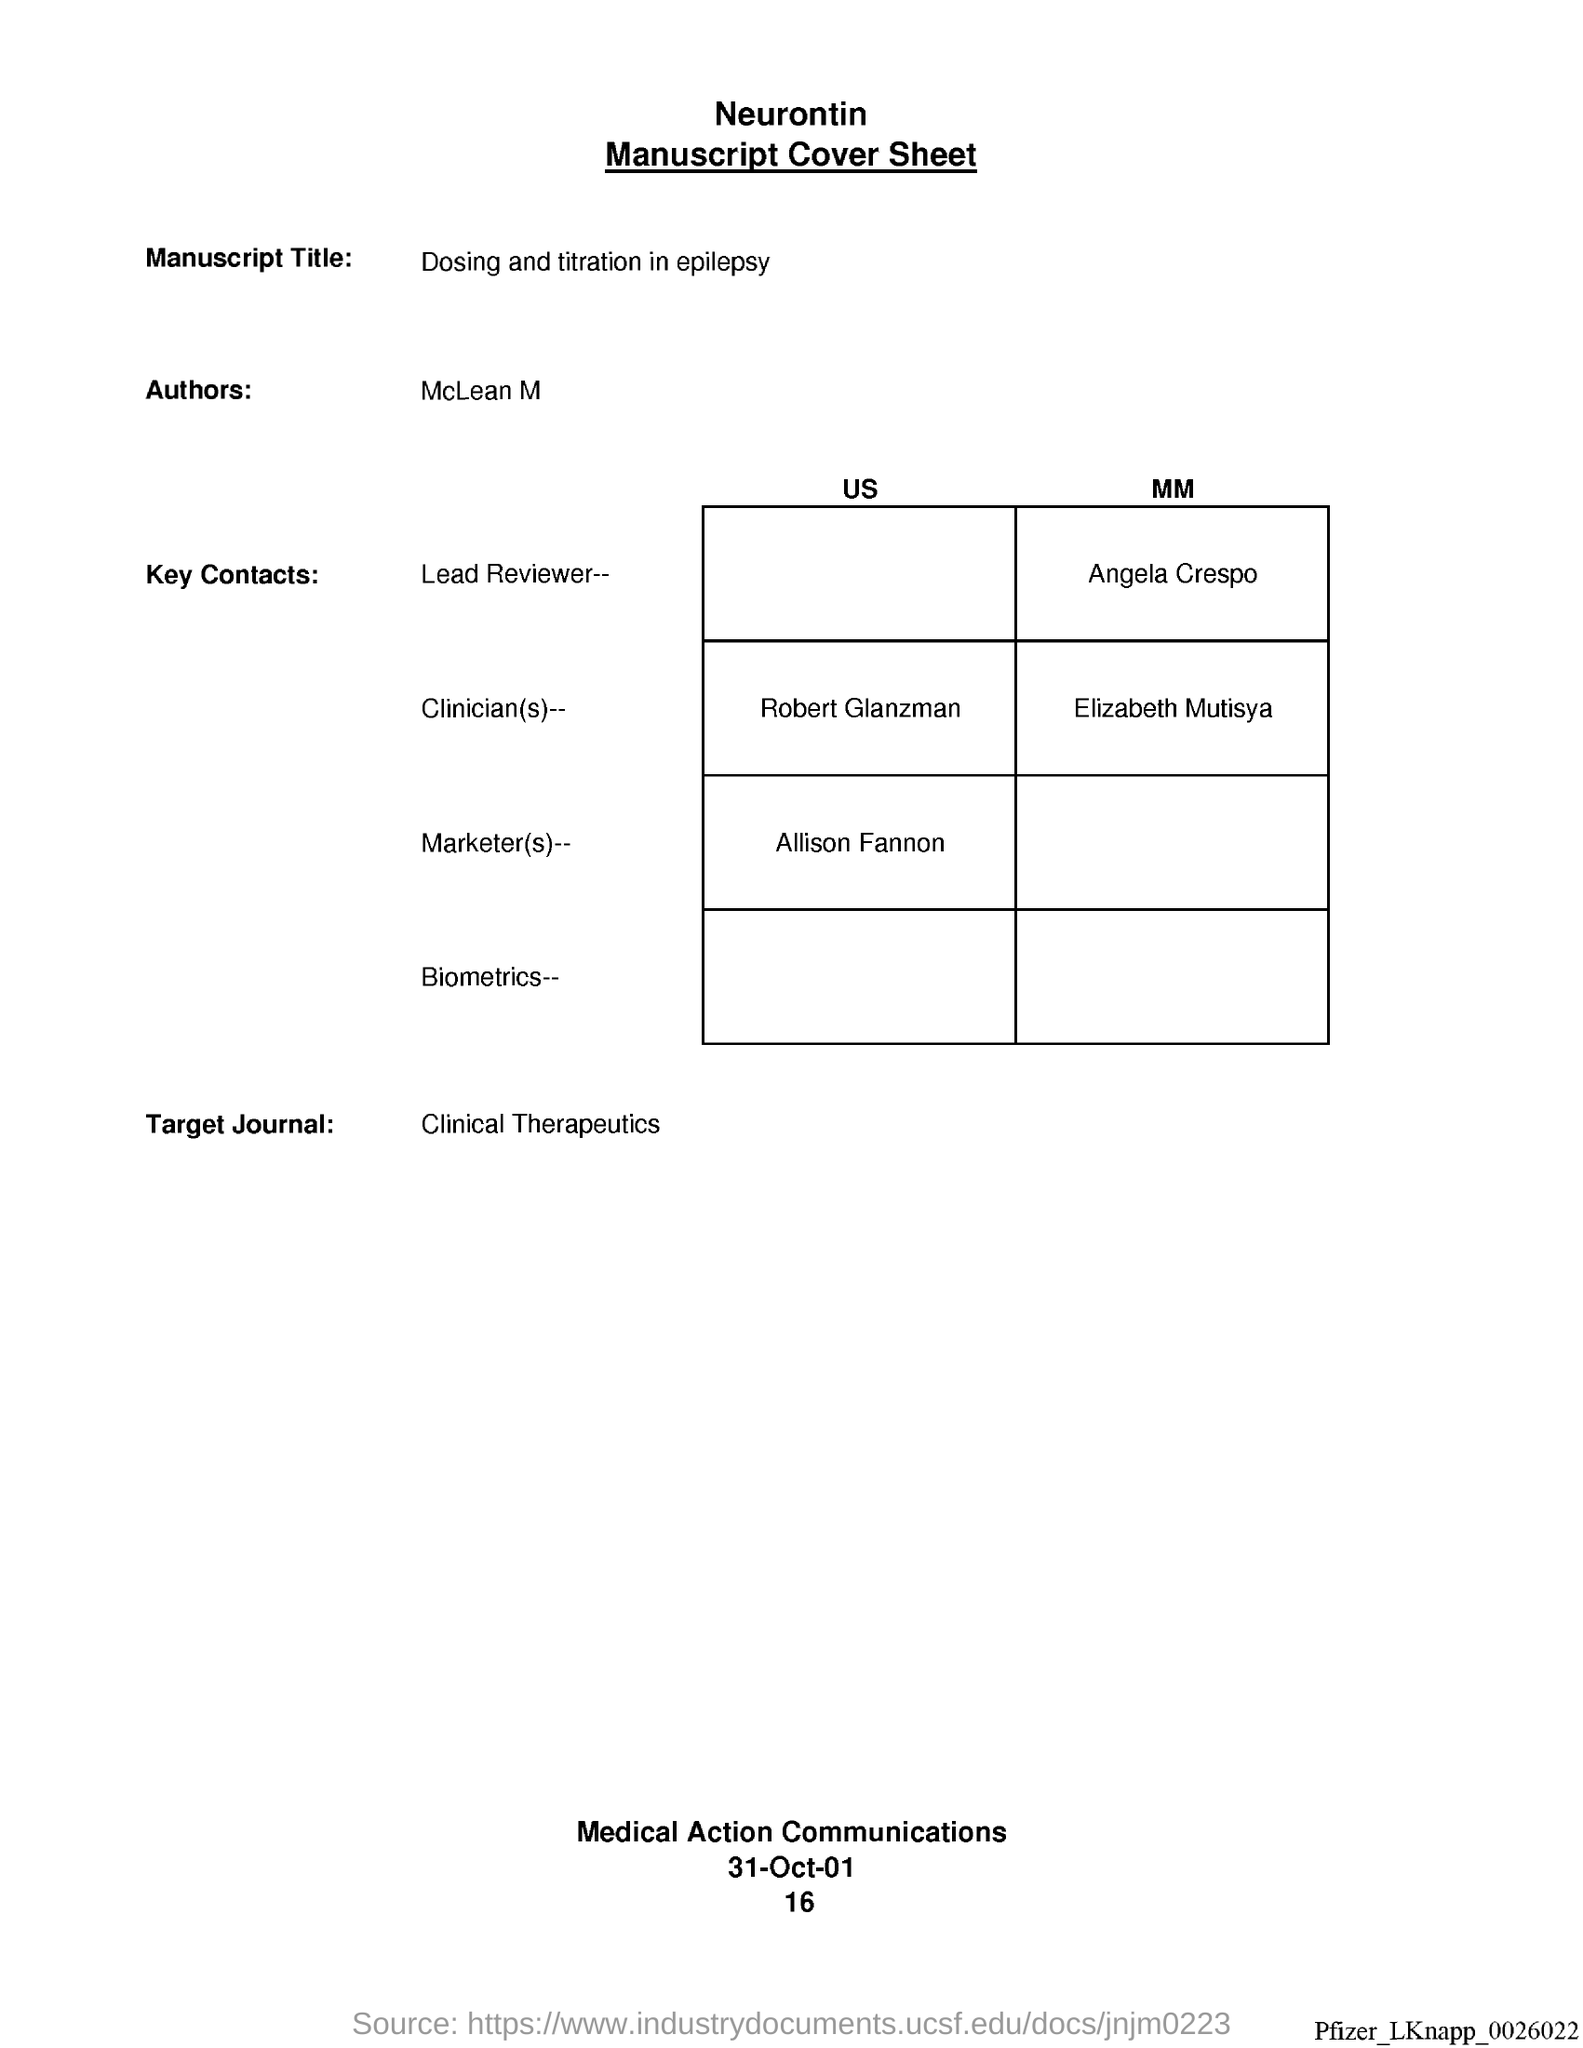Mention a couple of crucial points in this snapshot. The author of this text is McLean M.. The Target Journal is a publication named Clinical Therapeutics. The date is 31 October 2001. The manuscript title is "Dosing and titration in epilepsy. 